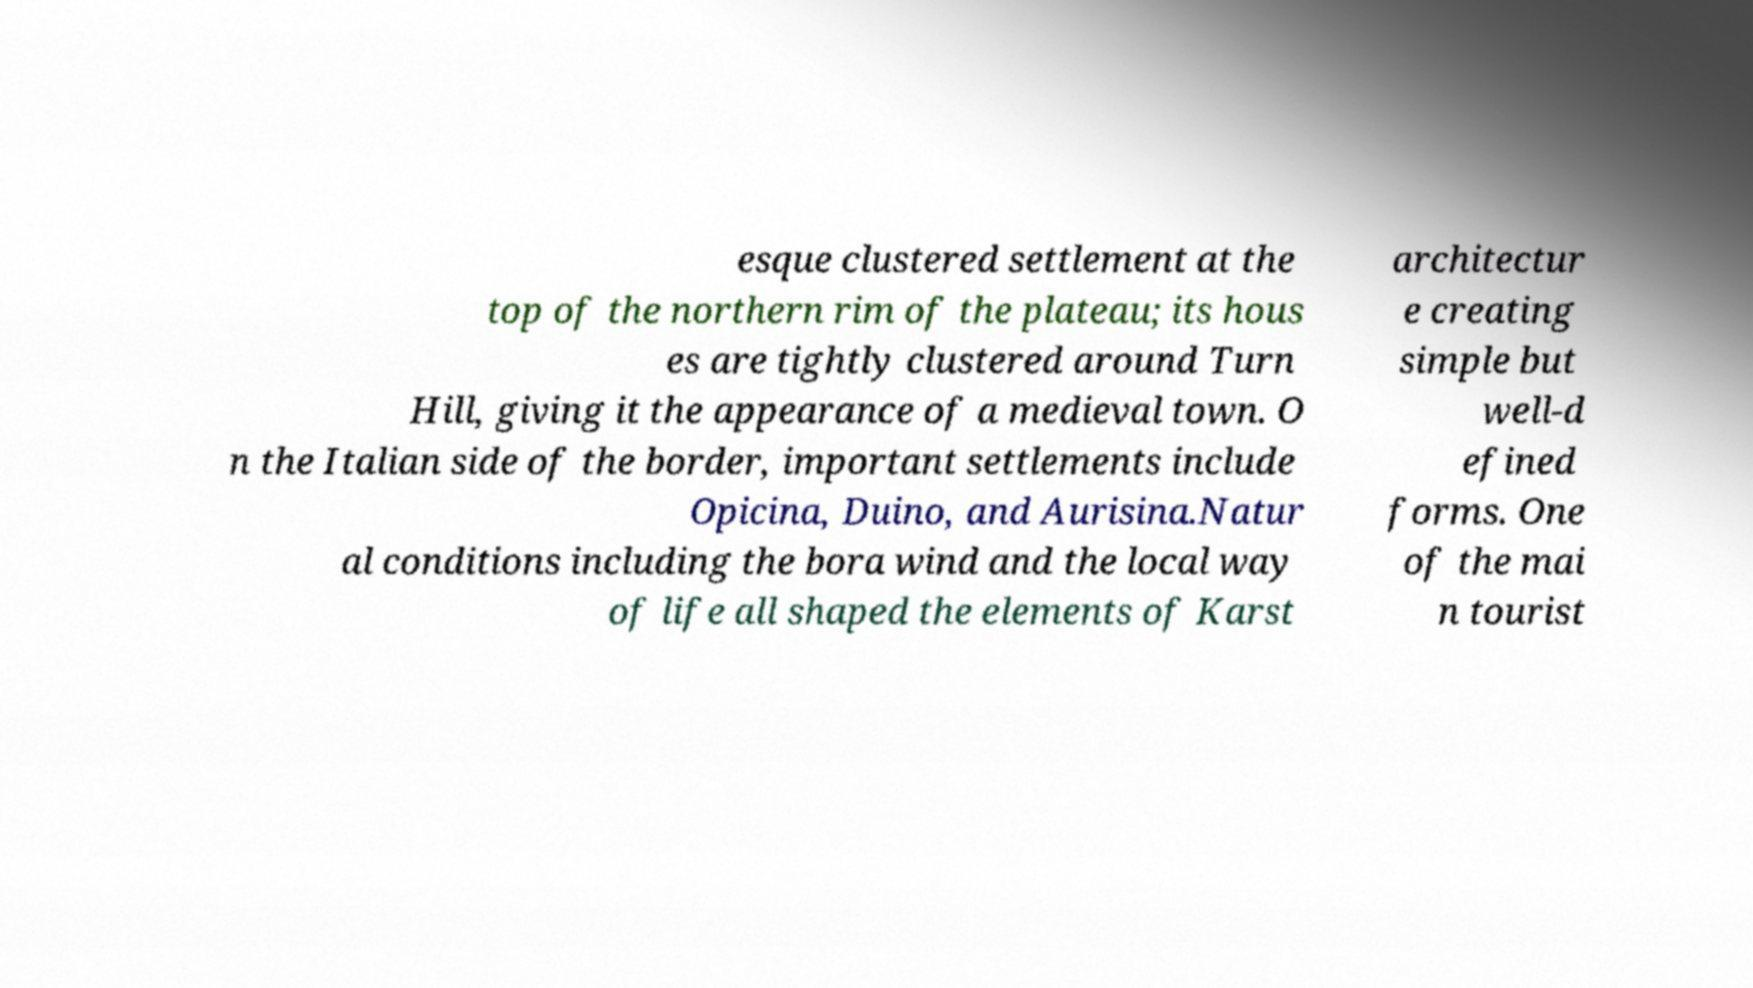Could you assist in decoding the text presented in this image and type it out clearly? esque clustered settlement at the top of the northern rim of the plateau; its hous es are tightly clustered around Turn Hill, giving it the appearance of a medieval town. O n the Italian side of the border, important settlements include Opicina, Duino, and Aurisina.Natur al conditions including the bora wind and the local way of life all shaped the elements of Karst architectur e creating simple but well-d efined forms. One of the mai n tourist 